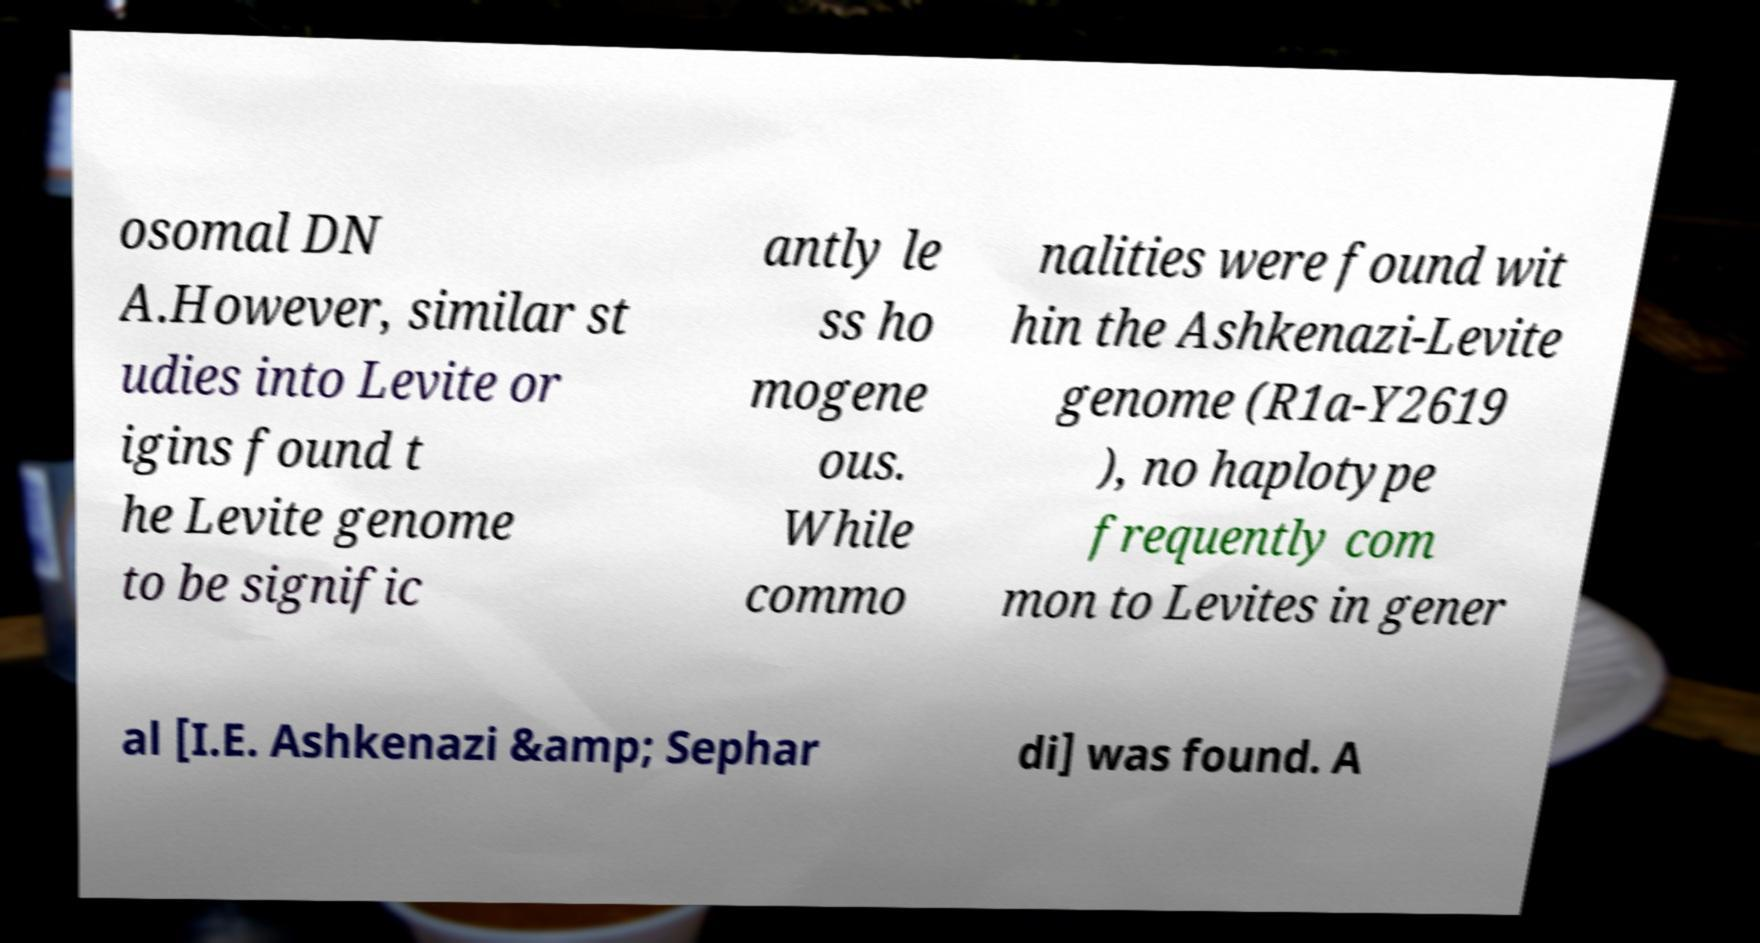Could you assist in decoding the text presented in this image and type it out clearly? osomal DN A.However, similar st udies into Levite or igins found t he Levite genome to be signific antly le ss ho mogene ous. While commo nalities were found wit hin the Ashkenazi-Levite genome (R1a-Y2619 ), no haplotype frequently com mon to Levites in gener al [I.E. Ashkenazi &amp; Sephar di] was found. A 